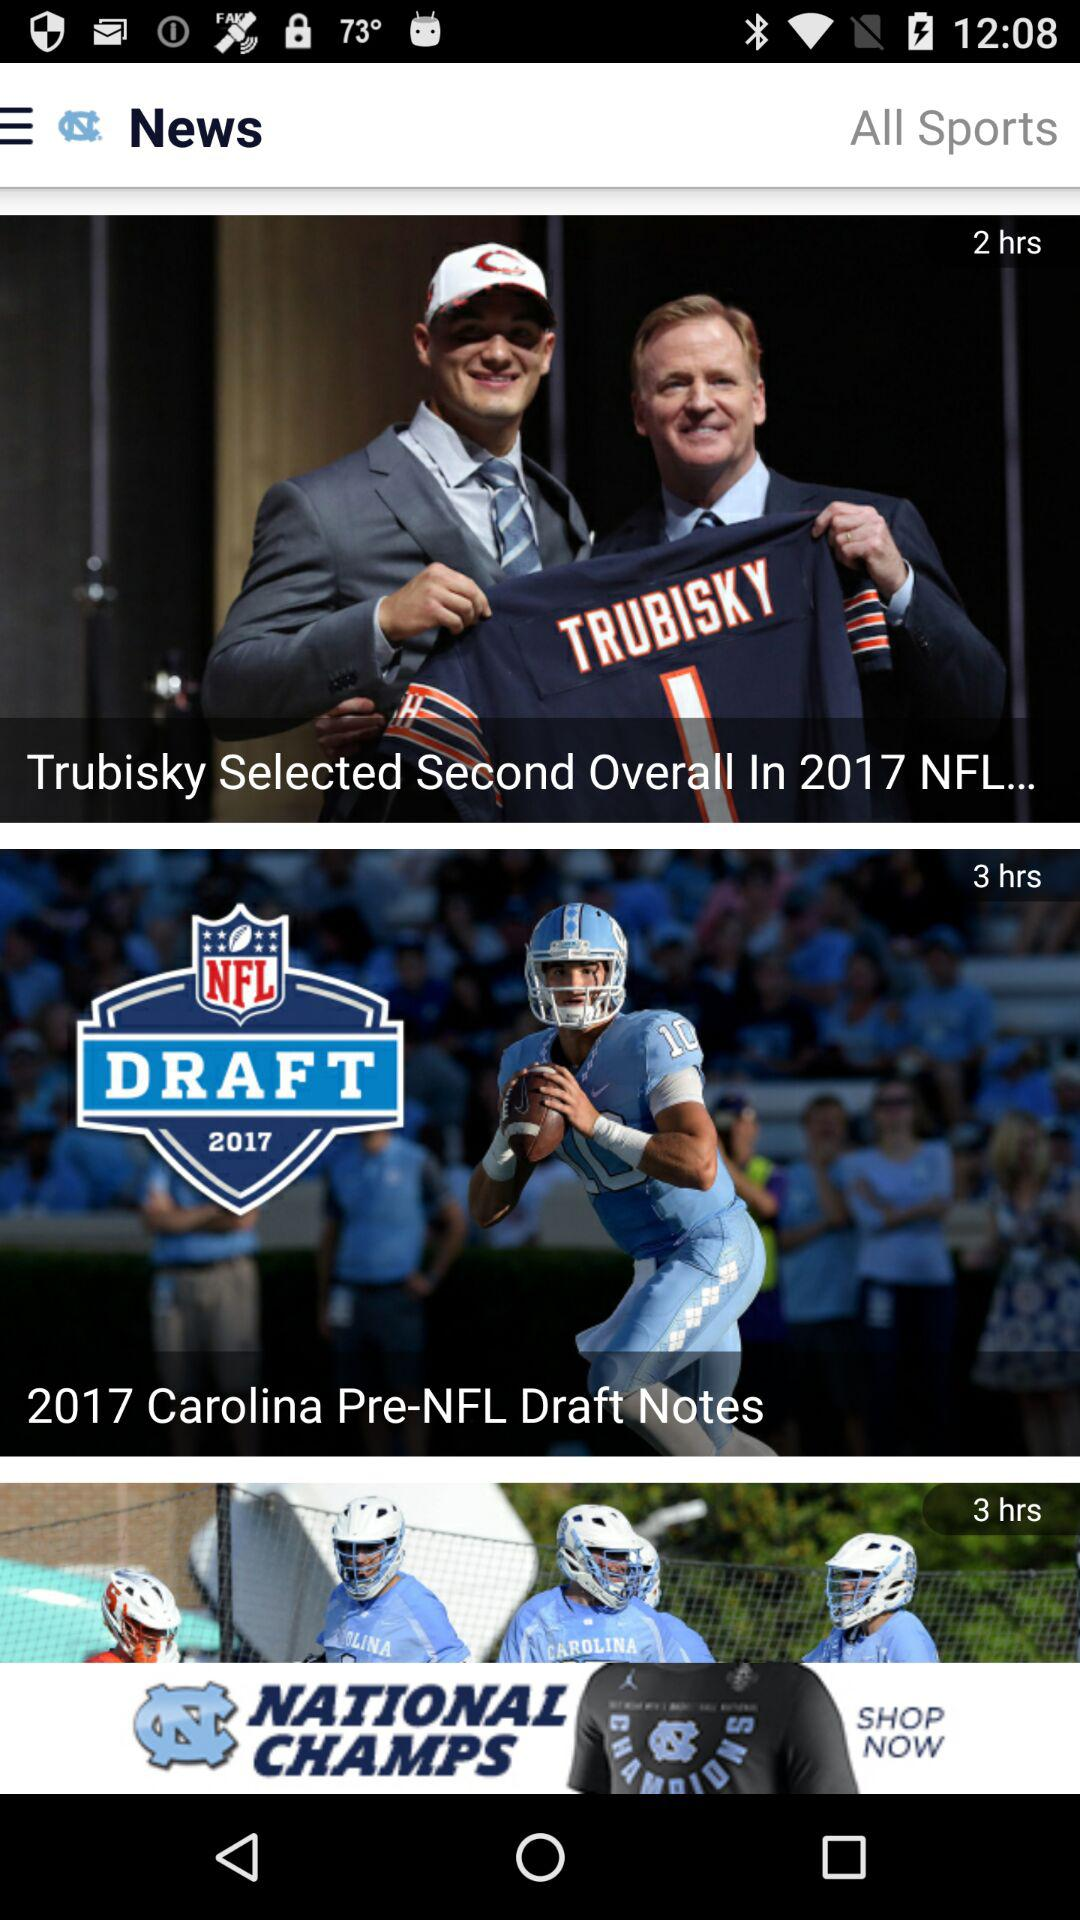What is the first post uploaded? The first post is "Trubisky Selected Second Overall In 2017 NFL...". 